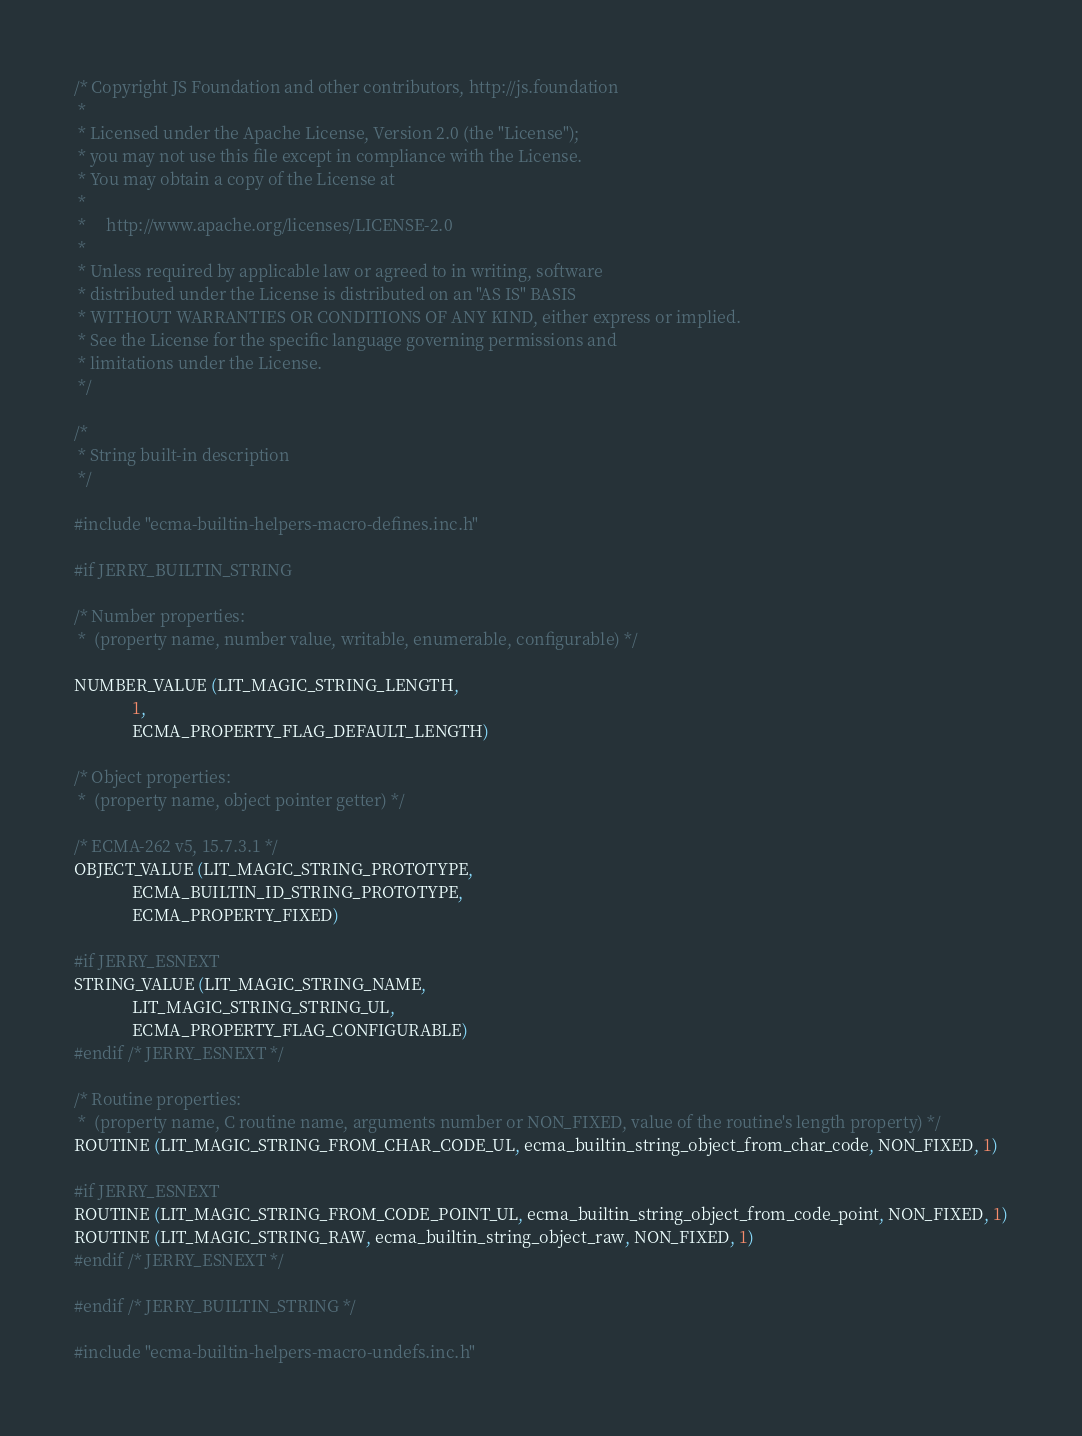<code> <loc_0><loc_0><loc_500><loc_500><_C_>/* Copyright JS Foundation and other contributors, http://js.foundation
 *
 * Licensed under the Apache License, Version 2.0 (the "License");
 * you may not use this file except in compliance with the License.
 * You may obtain a copy of the License at
 *
 *     http://www.apache.org/licenses/LICENSE-2.0
 *
 * Unless required by applicable law or agreed to in writing, software
 * distributed under the License is distributed on an "AS IS" BASIS
 * WITHOUT WARRANTIES OR CONDITIONS OF ANY KIND, either express or implied.
 * See the License for the specific language governing permissions and
 * limitations under the License.
 */

/*
 * String built-in description
 */

#include "ecma-builtin-helpers-macro-defines.inc.h"

#if JERRY_BUILTIN_STRING

/* Number properties:
 *  (property name, number value, writable, enumerable, configurable) */

NUMBER_VALUE (LIT_MAGIC_STRING_LENGTH,
              1,
              ECMA_PROPERTY_FLAG_DEFAULT_LENGTH)

/* Object properties:
 *  (property name, object pointer getter) */

/* ECMA-262 v5, 15.7.3.1 */
OBJECT_VALUE (LIT_MAGIC_STRING_PROTOTYPE,
              ECMA_BUILTIN_ID_STRING_PROTOTYPE,
              ECMA_PROPERTY_FIXED)

#if JERRY_ESNEXT
STRING_VALUE (LIT_MAGIC_STRING_NAME,
              LIT_MAGIC_STRING_STRING_UL,
              ECMA_PROPERTY_FLAG_CONFIGURABLE)
#endif /* JERRY_ESNEXT */

/* Routine properties:
 *  (property name, C routine name, arguments number or NON_FIXED, value of the routine's length property) */
ROUTINE (LIT_MAGIC_STRING_FROM_CHAR_CODE_UL, ecma_builtin_string_object_from_char_code, NON_FIXED, 1)

#if JERRY_ESNEXT
ROUTINE (LIT_MAGIC_STRING_FROM_CODE_POINT_UL, ecma_builtin_string_object_from_code_point, NON_FIXED, 1)
ROUTINE (LIT_MAGIC_STRING_RAW, ecma_builtin_string_object_raw, NON_FIXED, 1)
#endif /* JERRY_ESNEXT */

#endif /* JERRY_BUILTIN_STRING */

#include "ecma-builtin-helpers-macro-undefs.inc.h"
</code> 